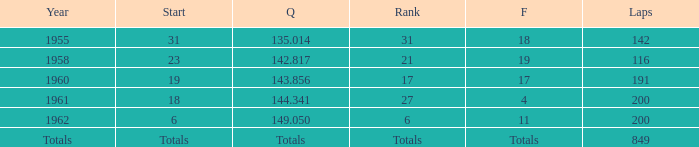What is the year with 116 laps? 1958.0. 